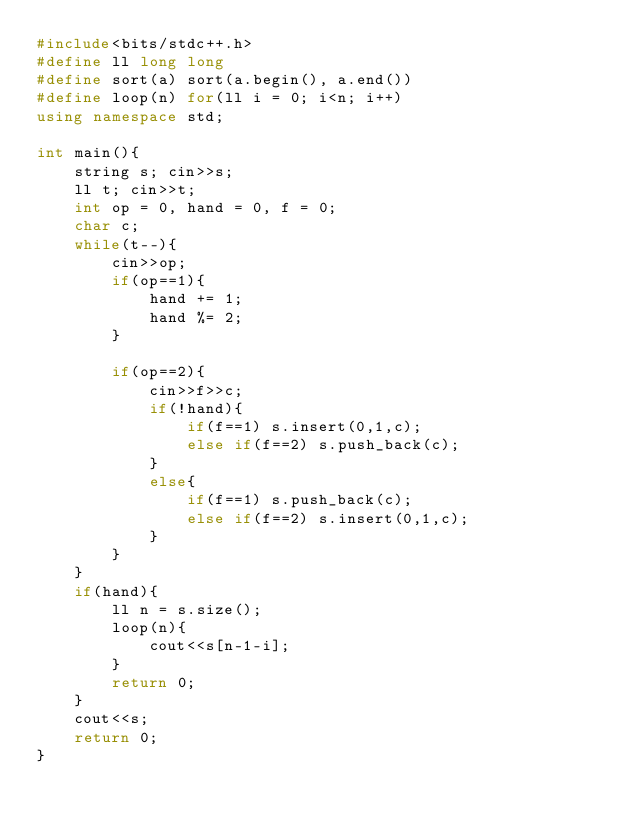Convert code to text. <code><loc_0><loc_0><loc_500><loc_500><_C++_>#include<bits/stdc++.h>
#define ll long long
#define sort(a) sort(a.begin(), a.end())
#define loop(n) for(ll i = 0; i<n; i++)
using namespace std;

int main(){
    string s; cin>>s;
    ll t; cin>>t;
    int op = 0, hand = 0, f = 0;
    char c;
    while(t--){
        cin>>op;
        if(op==1){
            hand += 1;
            hand %= 2;
        }

        if(op==2){
            cin>>f>>c;
            if(!hand){
                if(f==1) s.insert(0,1,c);
                else if(f==2) s.push_back(c);
            }
            else{
                if(f==1) s.push_back(c);
                else if(f==2) s.insert(0,1,c);
            }
        }
    }
    if(hand){
        ll n = s.size();
        loop(n){
            cout<<s[n-1-i];
        }   
        return 0;
    }
    cout<<s;
    return 0;
}</code> 